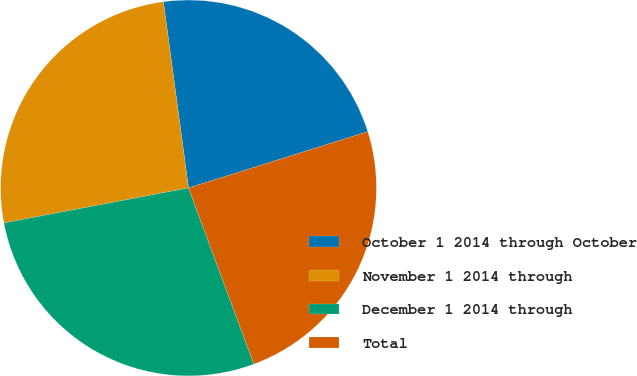<chart> <loc_0><loc_0><loc_500><loc_500><pie_chart><fcel>October 1 2014 through October<fcel>November 1 2014 through<fcel>December 1 2014 through<fcel>Total<nl><fcel>22.29%<fcel>25.85%<fcel>27.67%<fcel>24.19%<nl></chart> 